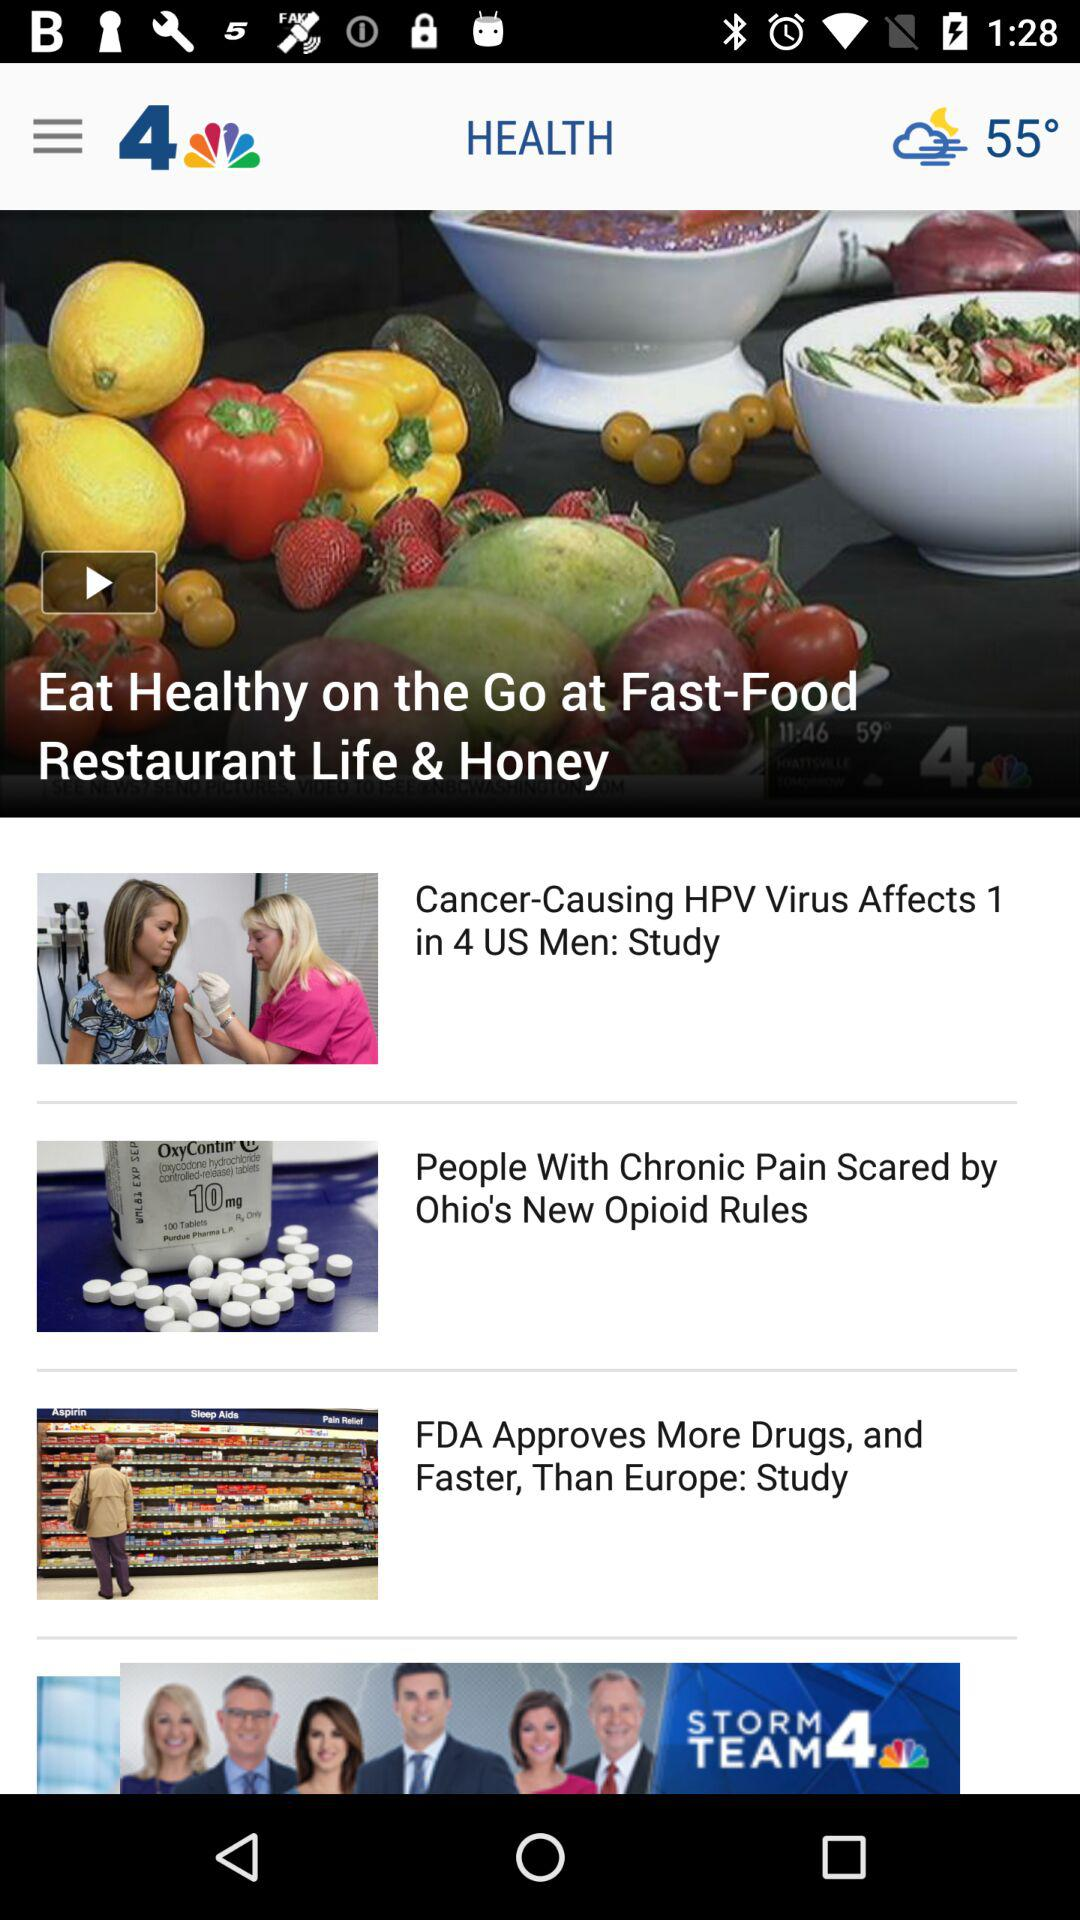How many degrees Fahrenheit is the current temperature?
Answer the question using a single word or phrase. 55° 